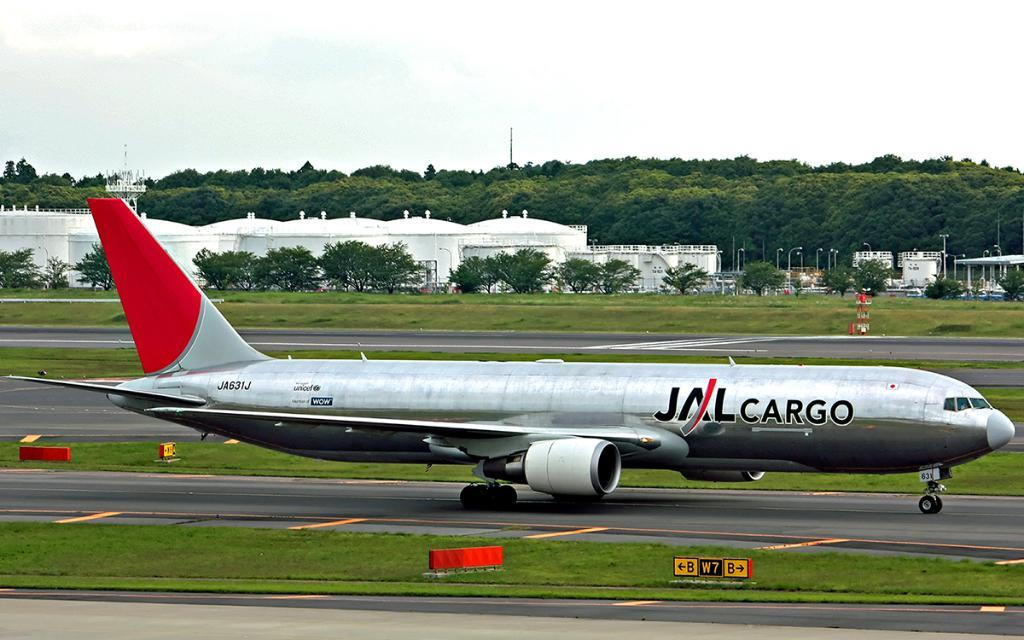What is the main subject in the center of the image? There is an aeroplane in the center of the image. What can be seen at the bottom of the image? There is a runway at the bottom of the image. What type of natural elements are visible in the background of the image? There are trees in the background of the image. What type of structures can be seen in the background of the image? There are tanks and sheds in the background of the image. What is visible in the sky in the background of the image? The sky is visible in the background of the image. What type of fiction is the aeroplane reading in the image? There is no indication in the image that the aeroplane is reading any fiction, as aeroplanes do not have the ability to read. 